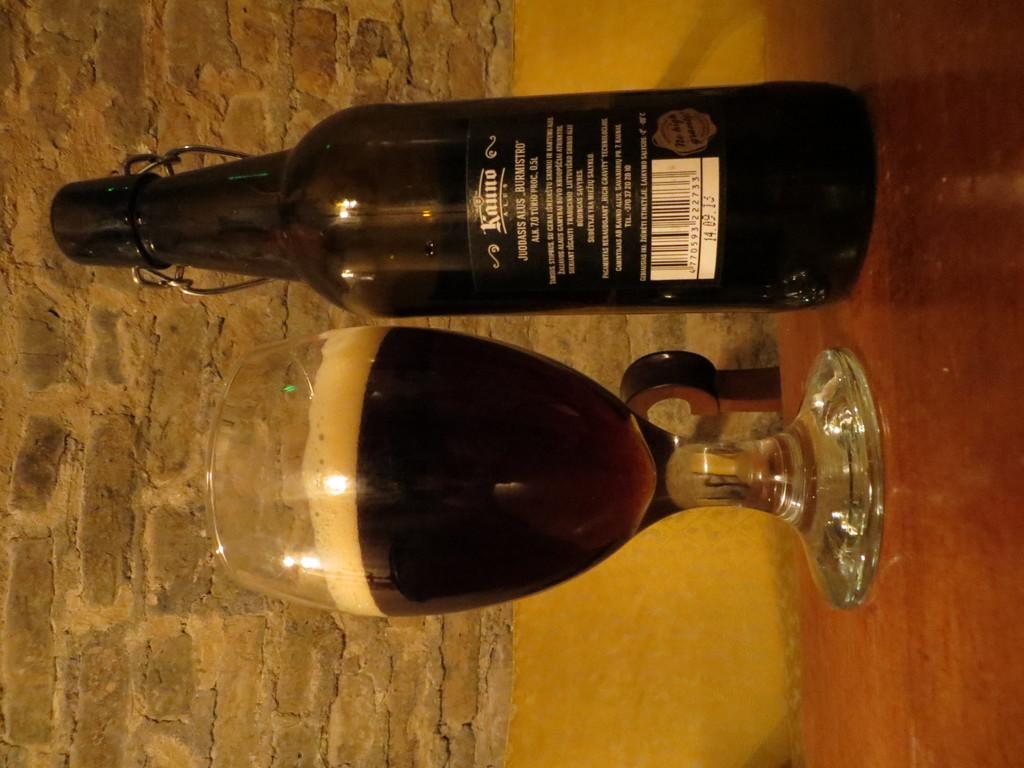<image>
Offer a succinct explanation of the picture presented. A 0.5L bottle of beer sits next to a glass containing the beer. 